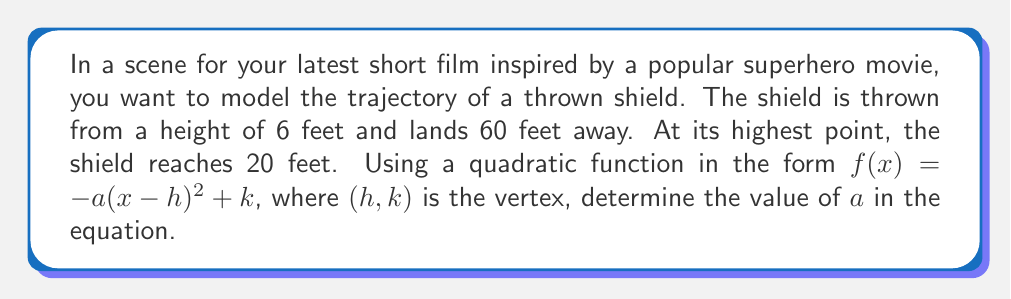Provide a solution to this math problem. Let's approach this step-by-step:

1) The general form of the quadratic function is $f(x)=-a(x-h)^2+k$, where $(h,k)$ is the vertex.

2) We know the shield reaches its highest point (vertex) at 20 feet. This gives us $k=20$.

3) The shield lands 60 feet away, so the x-coordinate of the vertex (h) is half of this: $h=30$.

4) Our function is now: $f(x)=-a(x-30)^2+20$

5) We know two points on this parabola:
   - Start: (0, 6)
   - End: (60, 0)

6) Let's use the start point (0, 6) to find $a$:

   $6 = -a(0-30)^2 + 20$
   $6 = -a(900) + 20$
   $-14 = -900a$
   $a = \frac{14}{900} = \frac{7}{450}$

7) We can verify this using the end point (60, 0):

   $0 = -\frac{7}{450}(60-30)^2 + 20$
   $0 = -\frac{7}{450}(900) + 20$
   $0 = -14 + 20$
   $0 = 6$ (This checks out)

Therefore, the value of $a$ in the equation is $\frac{7}{450}$.
Answer: $\frac{7}{450}$ 